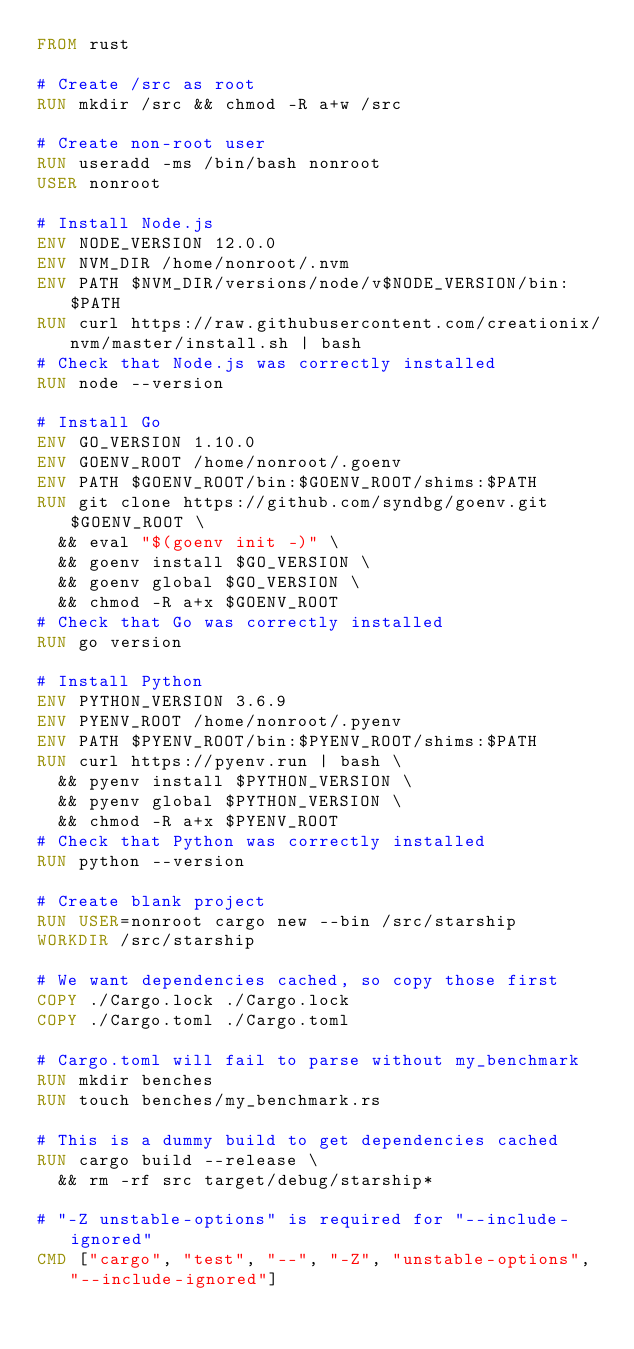<code> <loc_0><loc_0><loc_500><loc_500><_Dockerfile_>FROM rust

# Create /src as root
RUN mkdir /src && chmod -R a+w /src

# Create non-root user
RUN useradd -ms /bin/bash nonroot
USER nonroot

# Install Node.js
ENV NODE_VERSION 12.0.0
ENV NVM_DIR /home/nonroot/.nvm
ENV PATH $NVM_DIR/versions/node/v$NODE_VERSION/bin:$PATH
RUN curl https://raw.githubusercontent.com/creationix/nvm/master/install.sh | bash
# Check that Node.js was correctly installed
RUN node --version

# Install Go
ENV GO_VERSION 1.10.0
ENV GOENV_ROOT /home/nonroot/.goenv
ENV PATH $GOENV_ROOT/bin:$GOENV_ROOT/shims:$PATH
RUN git clone https://github.com/syndbg/goenv.git $GOENV_ROOT \
  && eval "$(goenv init -)" \
  && goenv install $GO_VERSION \
  && goenv global $GO_VERSION \
  && chmod -R a+x $GOENV_ROOT
# Check that Go was correctly installed
RUN go version

# Install Python
ENV PYTHON_VERSION 3.6.9
ENV PYENV_ROOT /home/nonroot/.pyenv
ENV PATH $PYENV_ROOT/bin:$PYENV_ROOT/shims:$PATH
RUN curl https://pyenv.run | bash \
  && pyenv install $PYTHON_VERSION \
  && pyenv global $PYTHON_VERSION \
  && chmod -R a+x $PYENV_ROOT
# Check that Python was correctly installed
RUN python --version

# Create blank project
RUN USER=nonroot cargo new --bin /src/starship
WORKDIR /src/starship

# We want dependencies cached, so copy those first
COPY ./Cargo.lock ./Cargo.lock
COPY ./Cargo.toml ./Cargo.toml

# Cargo.toml will fail to parse without my_benchmark
RUN mkdir benches
RUN touch benches/my_benchmark.rs

# This is a dummy build to get dependencies cached
RUN cargo build --release \
  && rm -rf src target/debug/starship*

# "-Z unstable-options" is required for "--include-ignored"
CMD ["cargo", "test", "--", "-Z", "unstable-options", "--include-ignored"]
</code> 